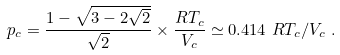Convert formula to latex. <formula><loc_0><loc_0><loc_500><loc_500>p _ { c } = \frac { 1 - \sqrt { 3 - 2 \sqrt { 2 } } } { \sqrt { 2 } } \times \frac { R T _ { c } } { V _ { c } } \simeq 0 . 4 1 4 \ R T _ { c } / V _ { c } \ .</formula> 